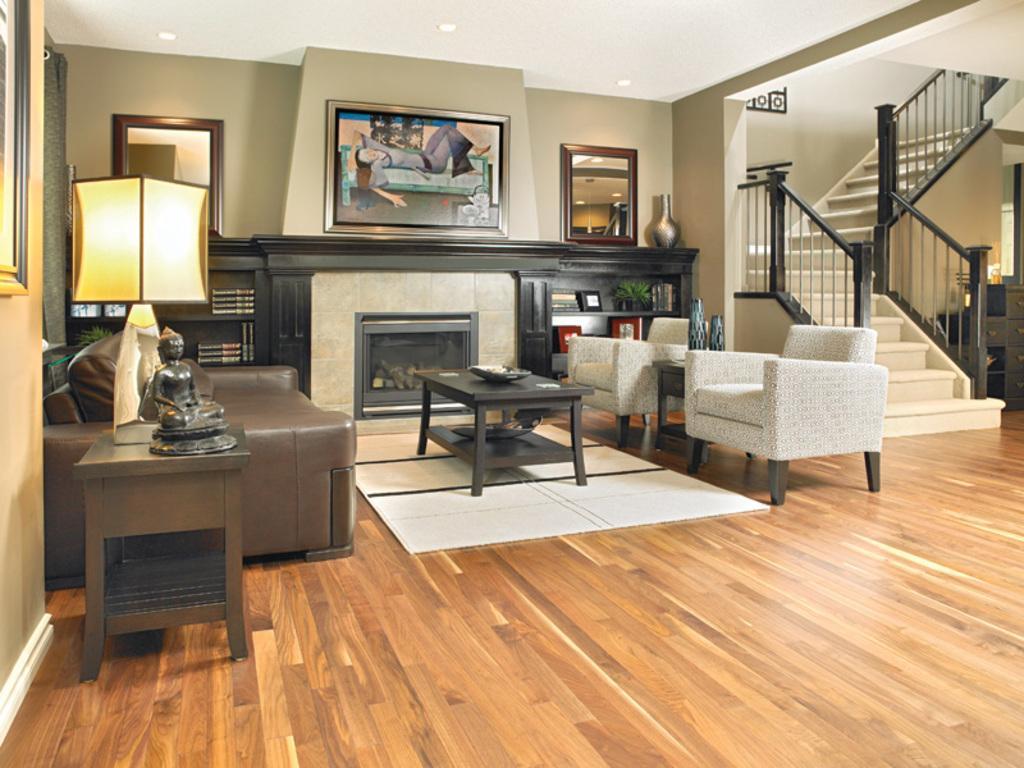Describe this image in one or two sentences. In the image we can see there is a living area of a house where we can see there are stairs, two chair and one sofa and on the wall there are photo frames and on table there is a statue of a person. 